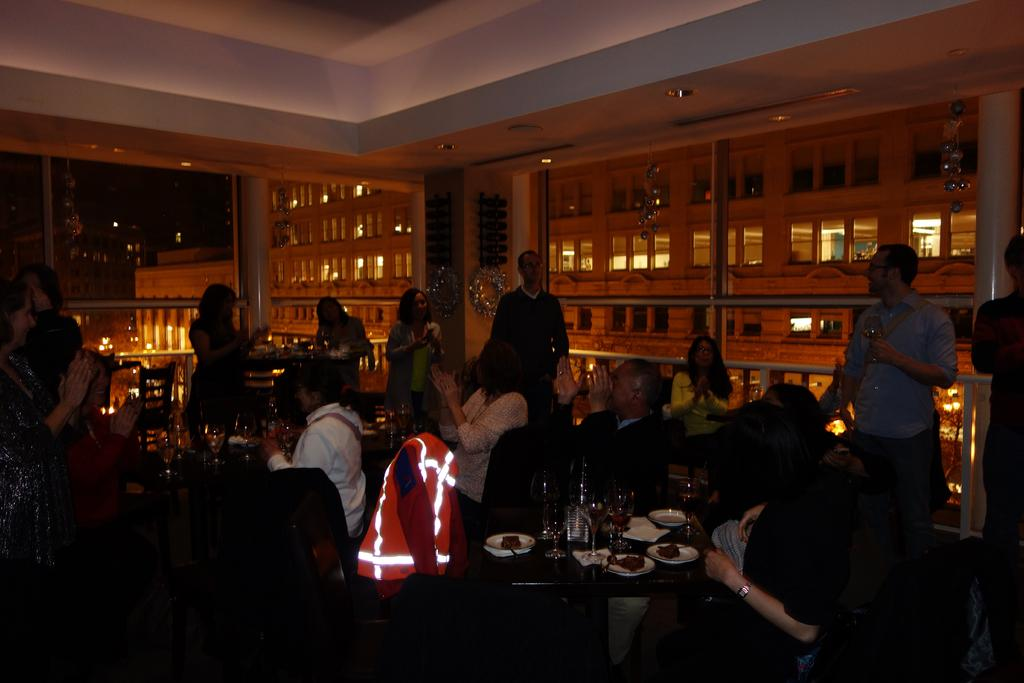How many people are in the image? There is a group of people in the image, but the exact number is not specified. What are the people in the image doing? Some people are sitting, while others are standing. What items can be seen on the table in the image? There are plates and glasses on the table. What can be seen in the background of the image? There are lights visible in the background. How many quarters are on the table in the image? There is no mention of quarters on the table in the image. Can you tell me which tooth is missing from the person standing in the image? There is no information about anyone's teeth in the image. 